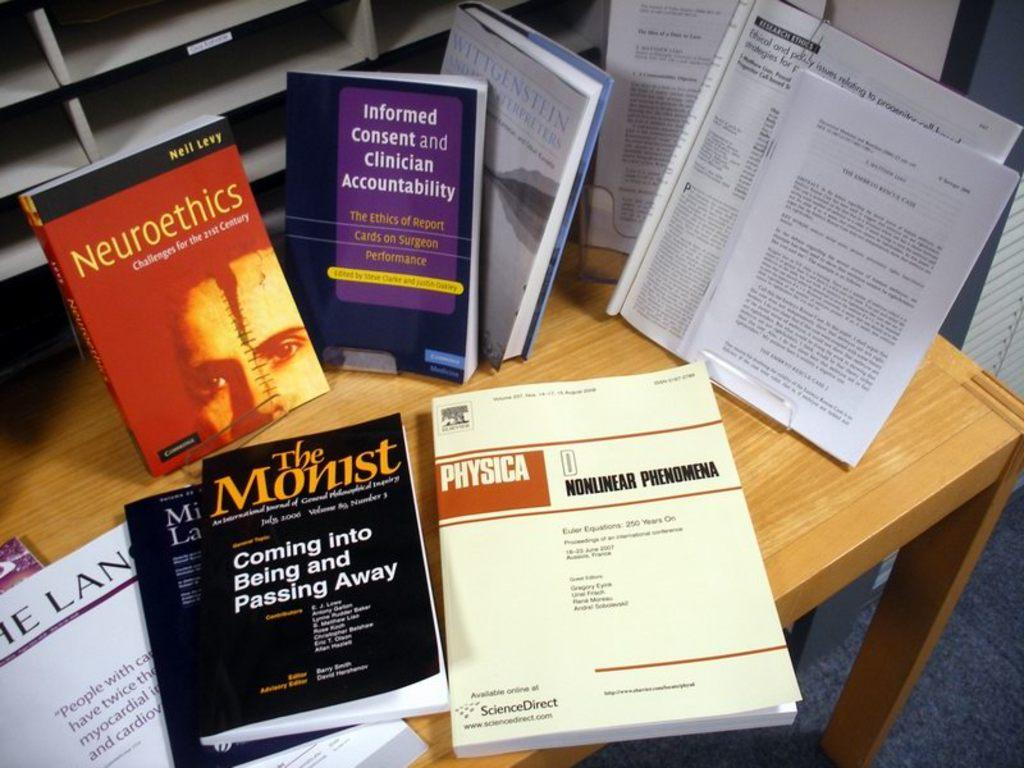<image>
Give a short and clear explanation of the subsequent image. A table full of text books including a book about nuclear phemomena and another covering coming into being and passing away. 